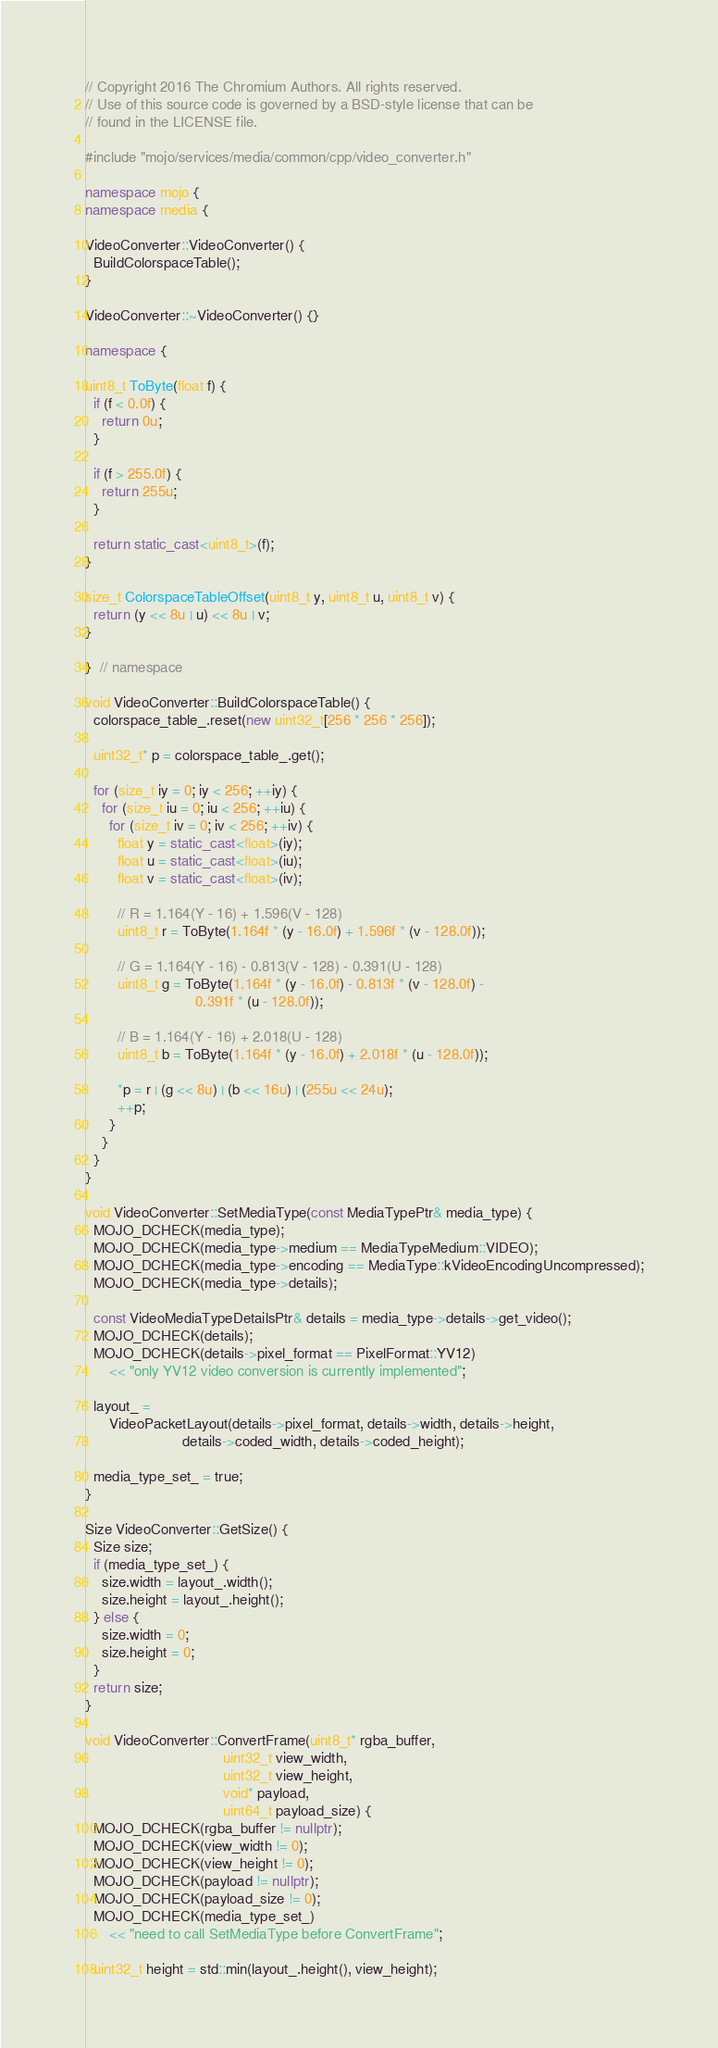<code> <loc_0><loc_0><loc_500><loc_500><_C++_>// Copyright 2016 The Chromium Authors. All rights reserved.
// Use of this source code is governed by a BSD-style license that can be
// found in the LICENSE file.

#include "mojo/services/media/common/cpp/video_converter.h"

namespace mojo {
namespace media {

VideoConverter::VideoConverter() {
  BuildColorspaceTable();
}

VideoConverter::~VideoConverter() {}

namespace {

uint8_t ToByte(float f) {
  if (f < 0.0f) {
    return 0u;
  }

  if (f > 255.0f) {
    return 255u;
  }

  return static_cast<uint8_t>(f);
}

size_t ColorspaceTableOffset(uint8_t y, uint8_t u, uint8_t v) {
  return (y << 8u | u) << 8u | v;
}

}  // namespace

void VideoConverter::BuildColorspaceTable() {
  colorspace_table_.reset(new uint32_t[256 * 256 * 256]);

  uint32_t* p = colorspace_table_.get();

  for (size_t iy = 0; iy < 256; ++iy) {
    for (size_t iu = 0; iu < 256; ++iu) {
      for (size_t iv = 0; iv < 256; ++iv) {
        float y = static_cast<float>(iy);
        float u = static_cast<float>(iu);
        float v = static_cast<float>(iv);

        // R = 1.164(Y - 16) + 1.596(V - 128)
        uint8_t r = ToByte(1.164f * (y - 16.0f) + 1.596f * (v - 128.0f));

        // G = 1.164(Y - 16) - 0.813(V - 128) - 0.391(U - 128)
        uint8_t g = ToByte(1.164f * (y - 16.0f) - 0.813f * (v - 128.0f) -
                           0.391f * (u - 128.0f));

        // B = 1.164(Y - 16) + 2.018(U - 128)
        uint8_t b = ToByte(1.164f * (y - 16.0f) + 2.018f * (u - 128.0f));

        *p = r | (g << 8u) | (b << 16u) | (255u << 24u);
        ++p;
      }
    }
  }
}

void VideoConverter::SetMediaType(const MediaTypePtr& media_type) {
  MOJO_DCHECK(media_type);
  MOJO_DCHECK(media_type->medium == MediaTypeMedium::VIDEO);
  MOJO_DCHECK(media_type->encoding == MediaType::kVideoEncodingUncompressed);
  MOJO_DCHECK(media_type->details);

  const VideoMediaTypeDetailsPtr& details = media_type->details->get_video();
  MOJO_DCHECK(details);
  MOJO_DCHECK(details->pixel_format == PixelFormat::YV12)
      << "only YV12 video conversion is currently implemented";

  layout_ =
      VideoPacketLayout(details->pixel_format, details->width, details->height,
                        details->coded_width, details->coded_height);

  media_type_set_ = true;
}

Size VideoConverter::GetSize() {
  Size size;
  if (media_type_set_) {
    size.width = layout_.width();
    size.height = layout_.height();
  } else {
    size.width = 0;
    size.height = 0;
  }
  return size;
}

void VideoConverter::ConvertFrame(uint8_t* rgba_buffer,
                                  uint32_t view_width,
                                  uint32_t view_height,
                                  void* payload,
                                  uint64_t payload_size) {
  MOJO_DCHECK(rgba_buffer != nullptr);
  MOJO_DCHECK(view_width != 0);
  MOJO_DCHECK(view_height != 0);
  MOJO_DCHECK(payload != nullptr);
  MOJO_DCHECK(payload_size != 0);
  MOJO_DCHECK(media_type_set_)
      << "need to call SetMediaType before ConvertFrame";

  uint32_t height = std::min(layout_.height(), view_height);</code> 